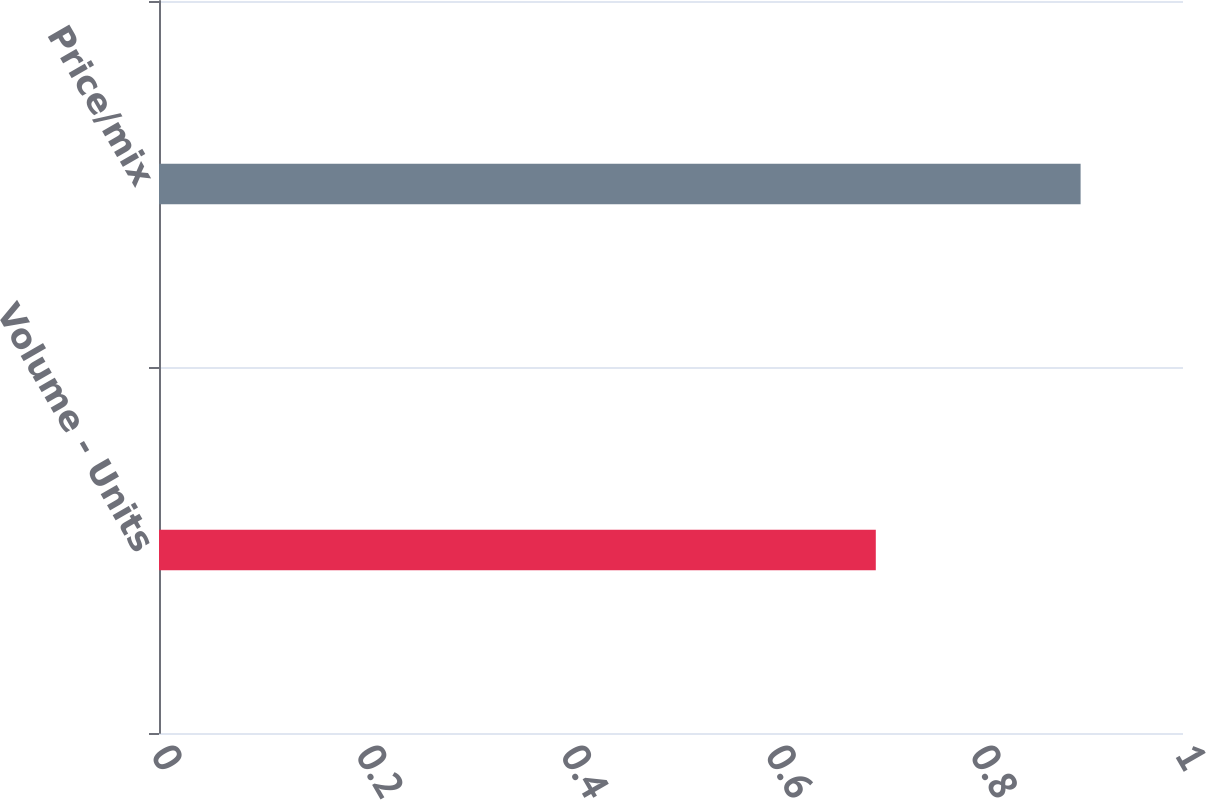Convert chart to OTSL. <chart><loc_0><loc_0><loc_500><loc_500><bar_chart><fcel>Volume - Units<fcel>Price/mix<nl><fcel>0.7<fcel>0.9<nl></chart> 